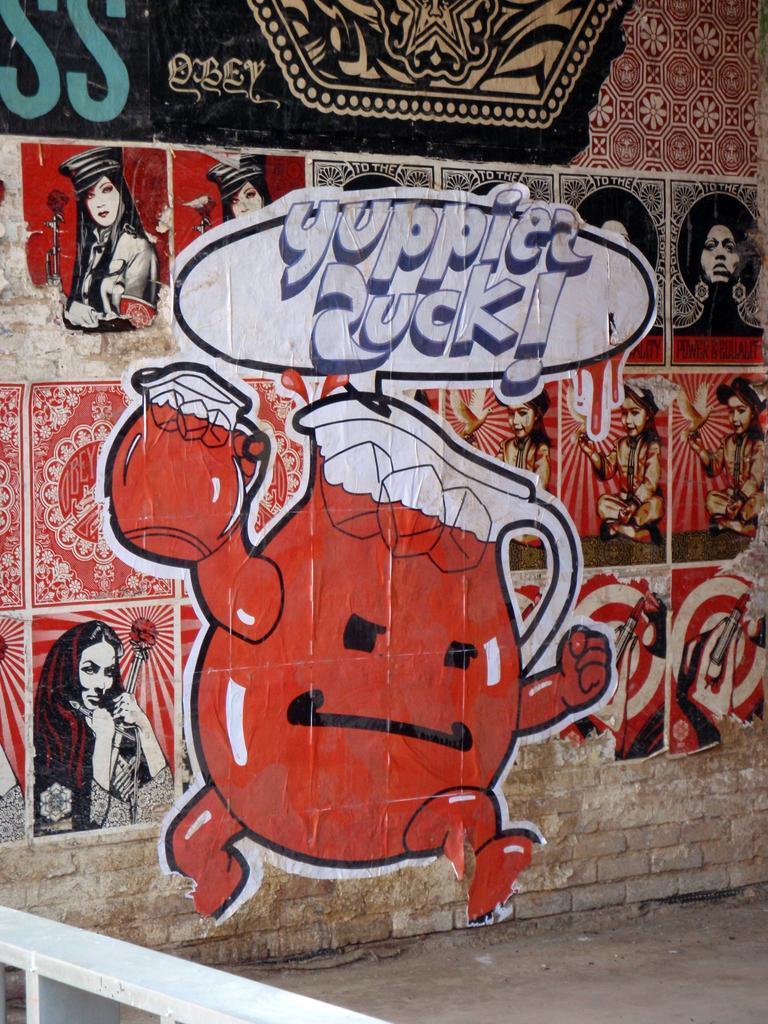Describe this image in one or two sentences. In the picture we can see a wall with some paintings of cartoons on it and near it, we can see a path and beside the wall we can see a part of the railing which is white in color. 